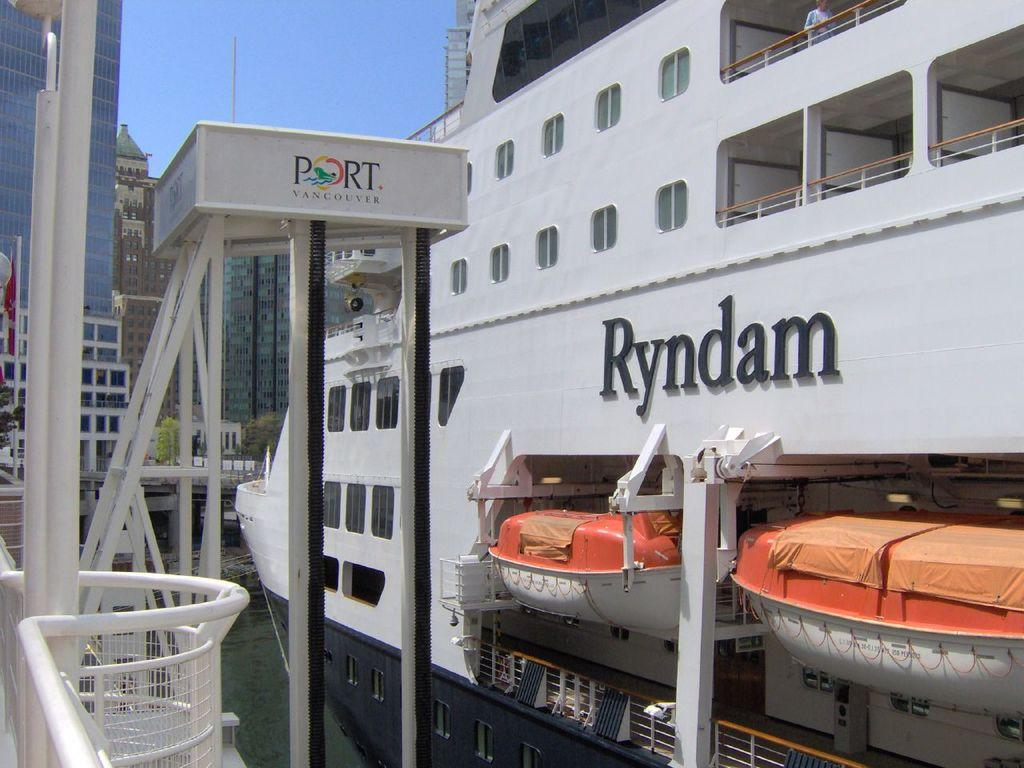<image>
Provide a brief description of the given image. A cruise ship in a port that reads Ryndam. 